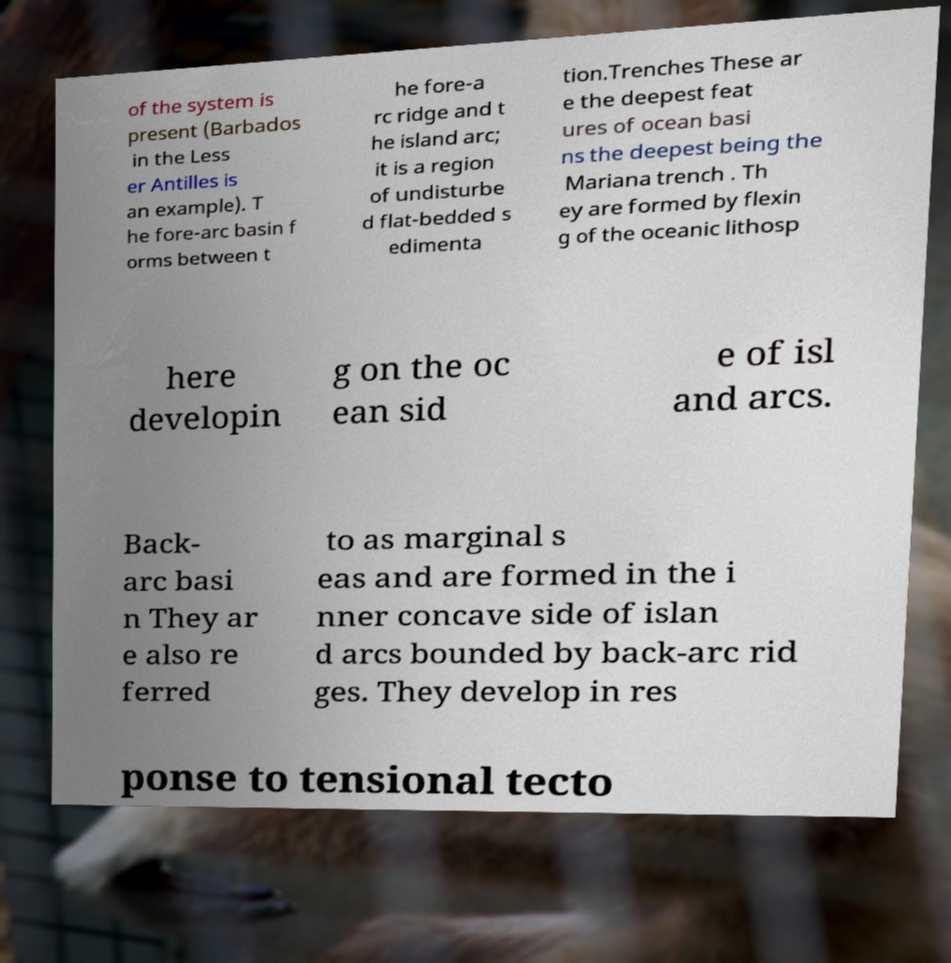What messages or text are displayed in this image? I need them in a readable, typed format. of the system is present (Barbados in the Less er Antilles is an example). T he fore-arc basin f orms between t he fore-a rc ridge and t he island arc; it is a region of undisturbe d flat-bedded s edimenta tion.Trenches These ar e the deepest feat ures of ocean basi ns the deepest being the Mariana trench . Th ey are formed by flexin g of the oceanic lithosp here developin g on the oc ean sid e of isl and arcs. Back- arc basi n They ar e also re ferred to as marginal s eas and are formed in the i nner concave side of islan d arcs bounded by back-arc rid ges. They develop in res ponse to tensional tecto 